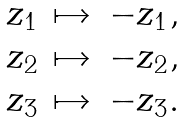Convert formula to latex. <formula><loc_0><loc_0><loc_500><loc_500>\begin{array} { r r r } z _ { 1 } & \mapsto & - z _ { 1 } , \\ z _ { 2 } & \mapsto & - z _ { 2 } , \\ z _ { 3 } & \mapsto & - z _ { 3 } . \end{array}</formula> 